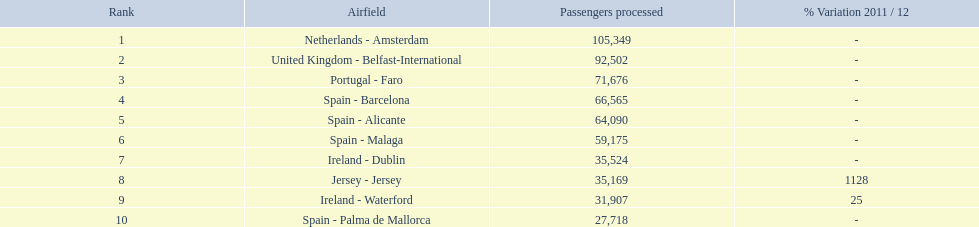What are all of the airports? Netherlands - Amsterdam, United Kingdom - Belfast-International, Portugal - Faro, Spain - Barcelona, Spain - Alicante, Spain - Malaga, Ireland - Dublin, Jersey - Jersey, Ireland - Waterford, Spain - Palma de Mallorca. How many passengers have they handled? 105,349, 92,502, 71,676, 66,565, 64,090, 59,175, 35,524, 35,169, 31,907, 27,718. And which airport has handled the most passengers? Netherlands - Amsterdam. 